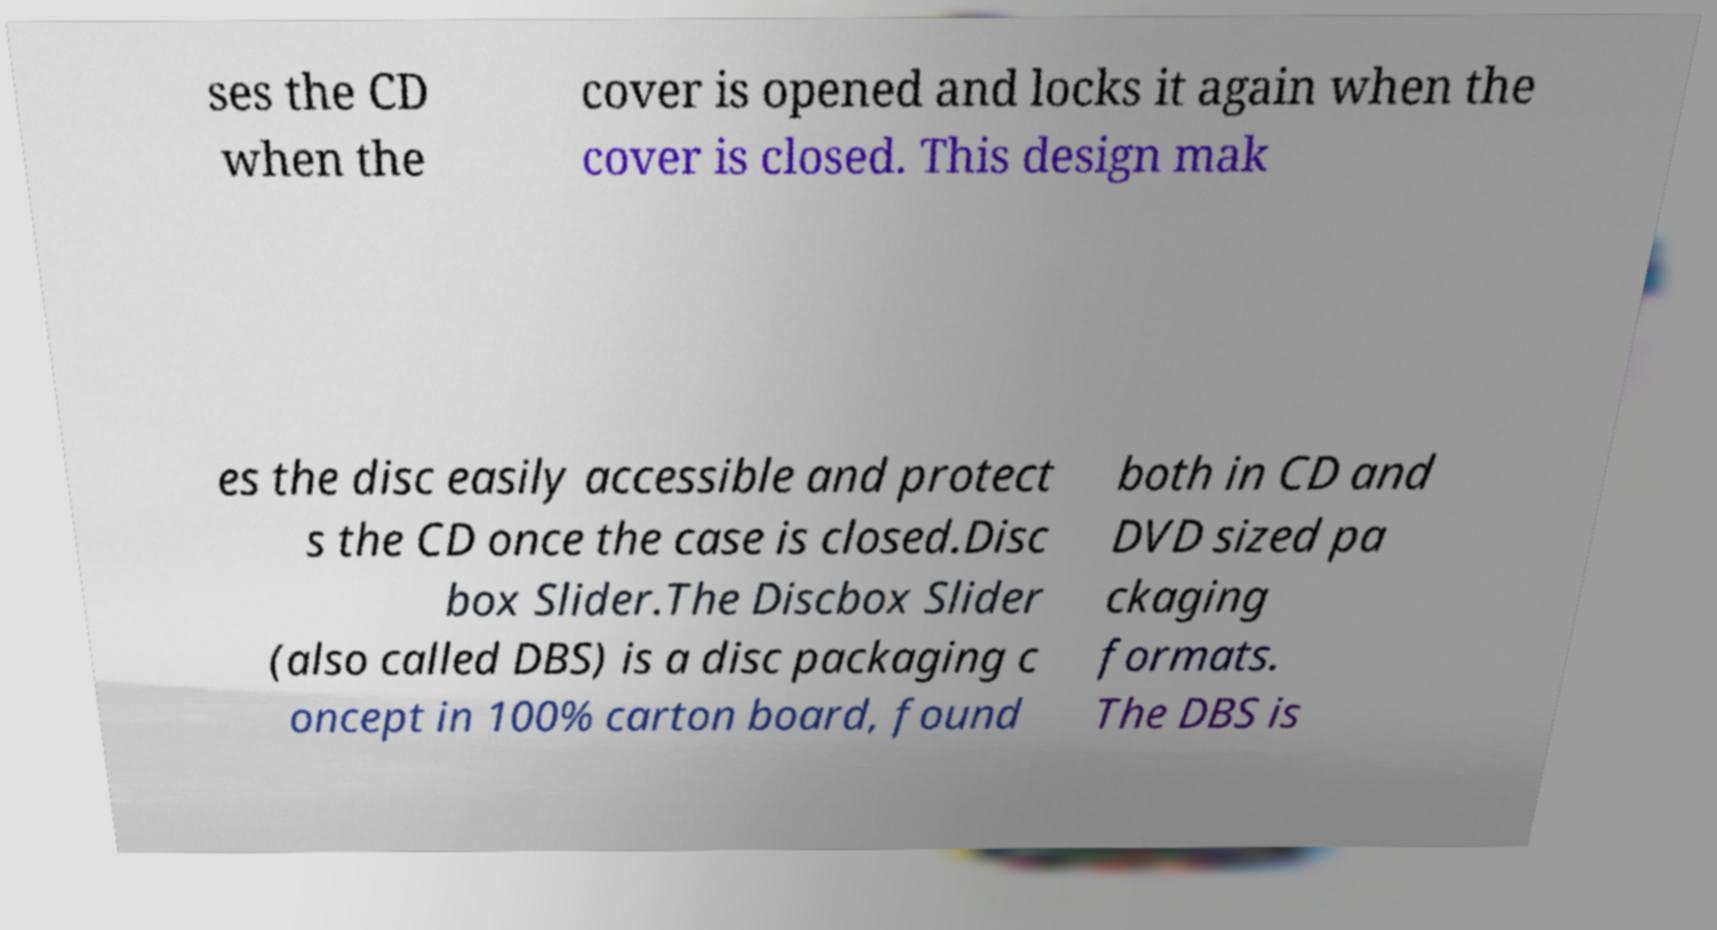There's text embedded in this image that I need extracted. Can you transcribe it verbatim? ses the CD when the cover is opened and locks it again when the cover is closed. This design mak es the disc easily accessible and protect s the CD once the case is closed.Disc box Slider.The Discbox Slider (also called DBS) is a disc packaging c oncept in 100% carton board, found both in CD and DVD sized pa ckaging formats. The DBS is 